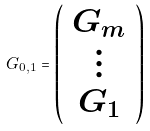Convert formula to latex. <formula><loc_0><loc_0><loc_500><loc_500>G _ { 0 , 1 } = \left ( \begin{array} { c } G _ { m } \\ \vdots \\ G _ { 1 } \end{array} \right )</formula> 